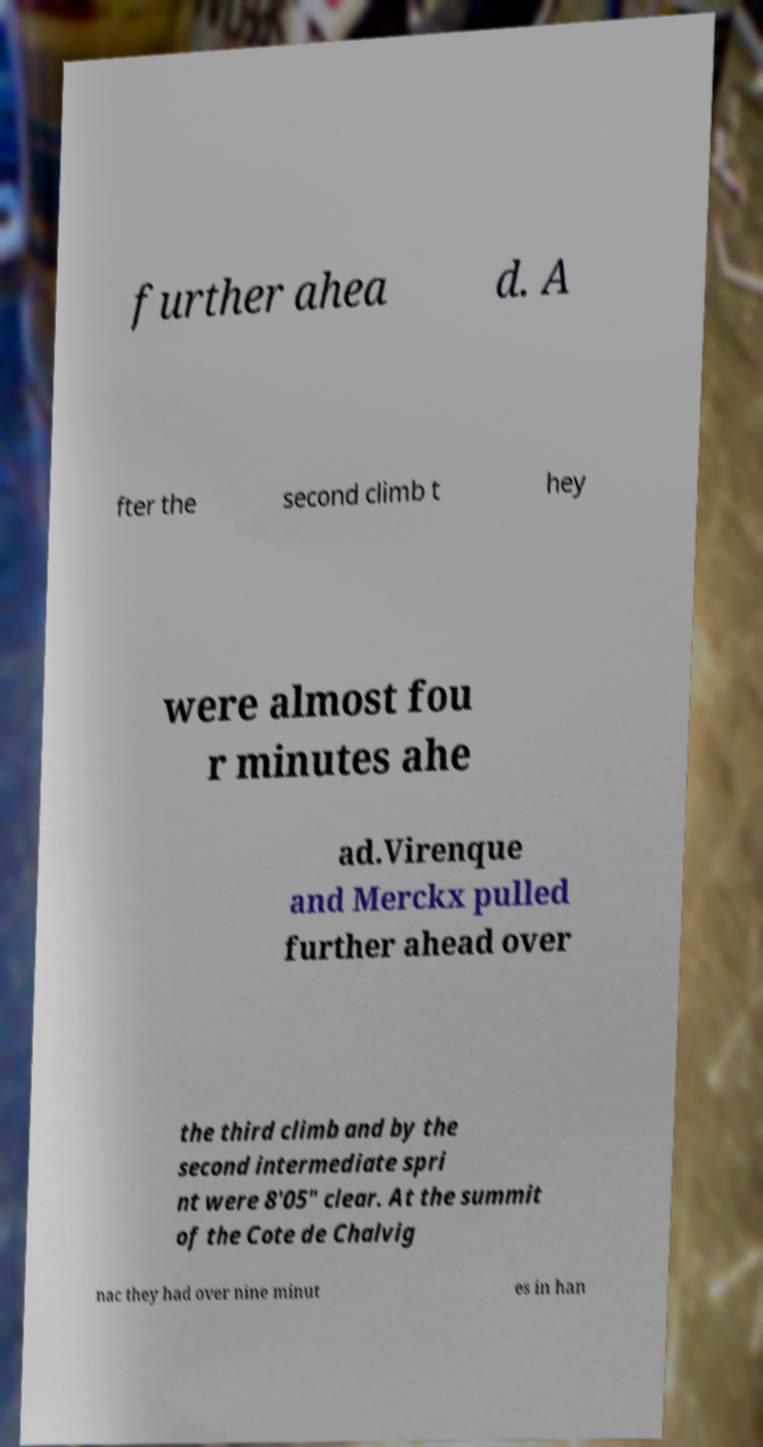What messages or text are displayed in this image? I need them in a readable, typed format. further ahea d. A fter the second climb t hey were almost fou r minutes ahe ad.Virenque and Merckx pulled further ahead over the third climb and by the second intermediate spri nt were 8'05" clear. At the summit of the Cote de Chalvig nac they had over nine minut es in han 